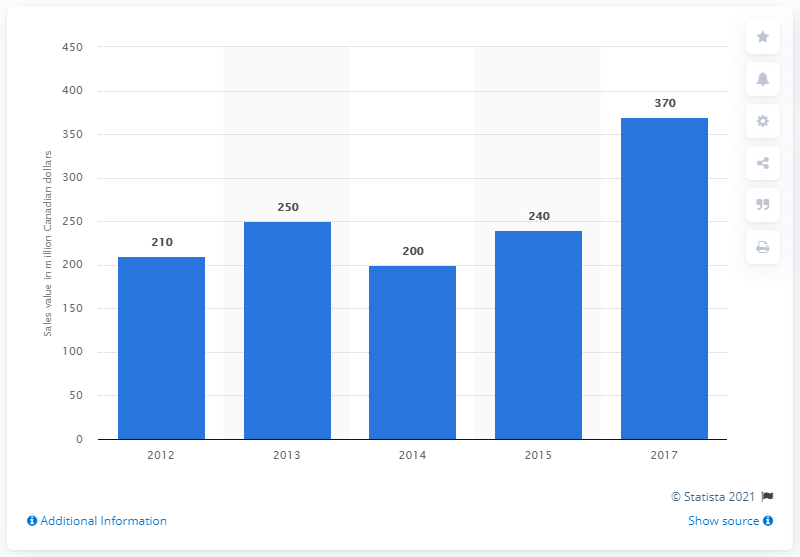Point out several critical features in this image. According to data from 2015, the sales value of craft beer in Ontario was approximately 240 million dollars. In 2017, the sales value of craft beer in Ontario was approximately CAD 370 million. 